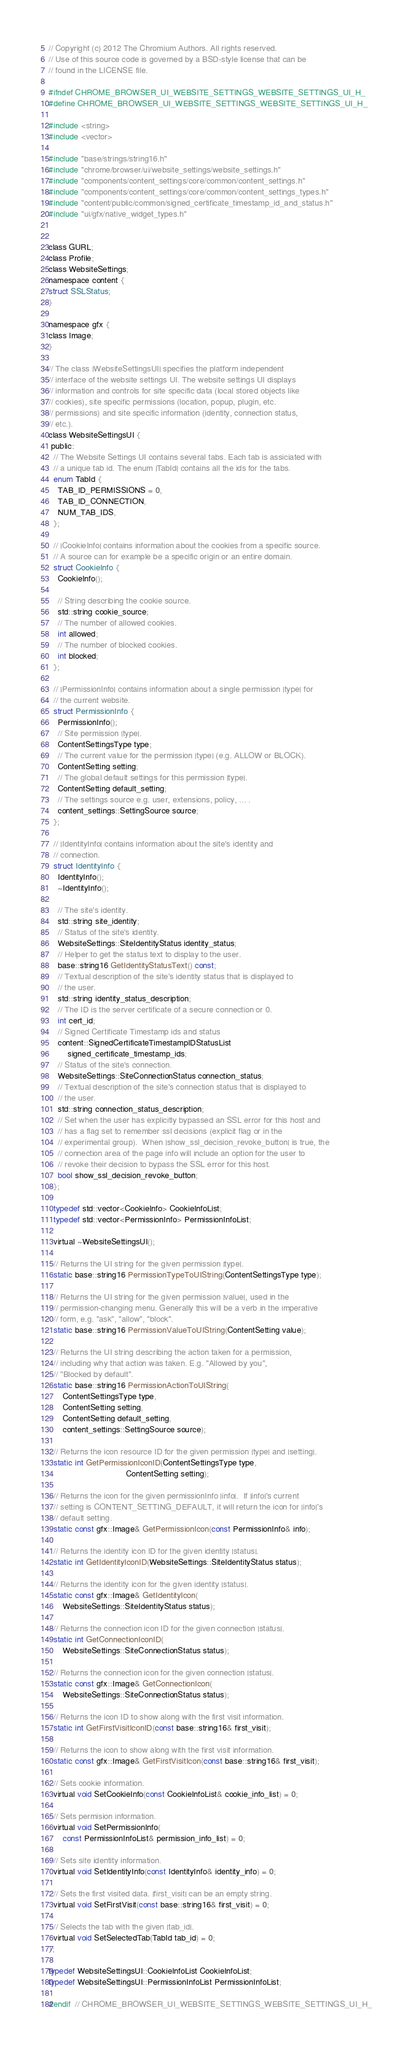Convert code to text. <code><loc_0><loc_0><loc_500><loc_500><_C_>// Copyright (c) 2012 The Chromium Authors. All rights reserved.
// Use of this source code is governed by a BSD-style license that can be
// found in the LICENSE file.

#ifndef CHROME_BROWSER_UI_WEBSITE_SETTINGS_WEBSITE_SETTINGS_UI_H_
#define CHROME_BROWSER_UI_WEBSITE_SETTINGS_WEBSITE_SETTINGS_UI_H_

#include <string>
#include <vector>

#include "base/strings/string16.h"
#include "chrome/browser/ui/website_settings/website_settings.h"
#include "components/content_settings/core/common/content_settings.h"
#include "components/content_settings/core/common/content_settings_types.h"
#include "content/public/common/signed_certificate_timestamp_id_and_status.h"
#include "ui/gfx/native_widget_types.h"


class GURL;
class Profile;
class WebsiteSettings;
namespace content {
struct SSLStatus;
}

namespace gfx {
class Image;
}

// The class |WebsiteSettingsUI| specifies the platform independent
// interface of the website settings UI. The website settings UI displays
// information and controls for site specific data (local stored objects like
// cookies), site specific permissions (location, popup, plugin, etc.
// permissions) and site specific information (identity, connection status,
// etc.).
class WebsiteSettingsUI {
 public:
  // The Website Settings UI contains several tabs. Each tab is assiciated with
  // a unique tab id. The enum |TabId| contains all the ids for the tabs.
  enum TabId {
    TAB_ID_PERMISSIONS = 0,
    TAB_ID_CONNECTION,
    NUM_TAB_IDS,
  };

  // |CookieInfo| contains information about the cookies from a specific source.
  // A source can for example be a specific origin or an entire domain.
  struct CookieInfo {
    CookieInfo();

    // String describing the cookie source.
    std::string cookie_source;
    // The number of allowed cookies.
    int allowed;
    // The number of blocked cookies.
    int blocked;
  };

  // |PermissionInfo| contains information about a single permission |type| for
  // the current website.
  struct PermissionInfo {
    PermissionInfo();
    // Site permission |type|.
    ContentSettingsType type;
    // The current value for the permission |type| (e.g. ALLOW or BLOCK).
    ContentSetting setting;
    // The global default settings for this permission |type|.
    ContentSetting default_setting;
    // The settings source e.g. user, extensions, policy, ... .
    content_settings::SettingSource source;
  };

  // |IdentityInfo| contains information about the site's identity and
  // connection.
  struct IdentityInfo {
    IdentityInfo();
    ~IdentityInfo();

    // The site's identity.
    std::string site_identity;
    // Status of the site's identity.
    WebsiteSettings::SiteIdentityStatus identity_status;
    // Helper to get the status text to display to the user.
    base::string16 GetIdentityStatusText() const;
    // Textual description of the site's identity status that is displayed to
    // the user.
    std::string identity_status_description;
    // The ID is the server certificate of a secure connection or 0.
    int cert_id;
    // Signed Certificate Timestamp ids and status
    content::SignedCertificateTimestampIDStatusList
        signed_certificate_timestamp_ids;
    // Status of the site's connection.
    WebsiteSettings::SiteConnectionStatus connection_status;
    // Textual description of the site's connection status that is displayed to
    // the user.
    std::string connection_status_description;
    // Set when the user has explicitly bypassed an SSL error for this host and
    // has a flag set to remember ssl decisions (explicit flag or in the
    // experimental group).  When |show_ssl_decision_revoke_button| is true, the
    // connection area of the page info will include an option for the user to
    // revoke their decision to bypass the SSL error for this host.
    bool show_ssl_decision_revoke_button;
  };

  typedef std::vector<CookieInfo> CookieInfoList;
  typedef std::vector<PermissionInfo> PermissionInfoList;

  virtual ~WebsiteSettingsUI();

  // Returns the UI string for the given permission |type|.
  static base::string16 PermissionTypeToUIString(ContentSettingsType type);

  // Returns the UI string for the given permission |value|, used in the
  // permission-changing menu. Generally this will be a verb in the imperative
  // form, e.g. "ask", "allow", "block".
  static base::string16 PermissionValueToUIString(ContentSetting value);

  // Returns the UI string describing the action taken for a permission,
  // including why that action was taken. E.g. "Allowed by you",
  // "Blocked by default".
  static base::string16 PermissionActionToUIString(
      ContentSettingsType type,
      ContentSetting setting,
      ContentSetting default_setting,
      content_settings::SettingSource source);

  // Returns the icon resource ID for the given permission |type| and |setting|.
  static int GetPermissionIconID(ContentSettingsType type,
                                 ContentSetting setting);

  // Returns the icon for the given permissionInfo |info|.  If |info|'s current
  // setting is CONTENT_SETTING_DEFAULT, it will return the icon for |info|'s
  // default setting.
  static const gfx::Image& GetPermissionIcon(const PermissionInfo& info);

  // Returns the identity icon ID for the given identity |status|.
  static int GetIdentityIconID(WebsiteSettings::SiteIdentityStatus status);

  // Returns the identity icon for the given identity |status|.
  static const gfx::Image& GetIdentityIcon(
      WebsiteSettings::SiteIdentityStatus status);

  // Returns the connection icon ID for the given connection |status|.
  static int GetConnectionIconID(
      WebsiteSettings::SiteConnectionStatus status);

  // Returns the connection icon for the given connection |status|.
  static const gfx::Image& GetConnectionIcon(
      WebsiteSettings::SiteConnectionStatus status);

  // Returns the icon ID to show along with the first visit information.
  static int GetFirstVisitIconID(const base::string16& first_visit);

  // Returns the icon to show along with the first visit information.
  static const gfx::Image& GetFirstVisitIcon(const base::string16& first_visit);

  // Sets cookie information.
  virtual void SetCookieInfo(const CookieInfoList& cookie_info_list) = 0;

  // Sets permision information.
  virtual void SetPermissionInfo(
      const PermissionInfoList& permission_info_list) = 0;

  // Sets site identity information.
  virtual void SetIdentityInfo(const IdentityInfo& identity_info) = 0;

  // Sets the first visited data. |first_visit| can be an empty string.
  virtual void SetFirstVisit(const base::string16& first_visit) = 0;

  // Selects the tab with the given |tab_id|.
  virtual void SetSelectedTab(TabId tab_id) = 0;
};

typedef WebsiteSettingsUI::CookieInfoList CookieInfoList;
typedef WebsiteSettingsUI::PermissionInfoList PermissionInfoList;

#endif  // CHROME_BROWSER_UI_WEBSITE_SETTINGS_WEBSITE_SETTINGS_UI_H_
</code> 